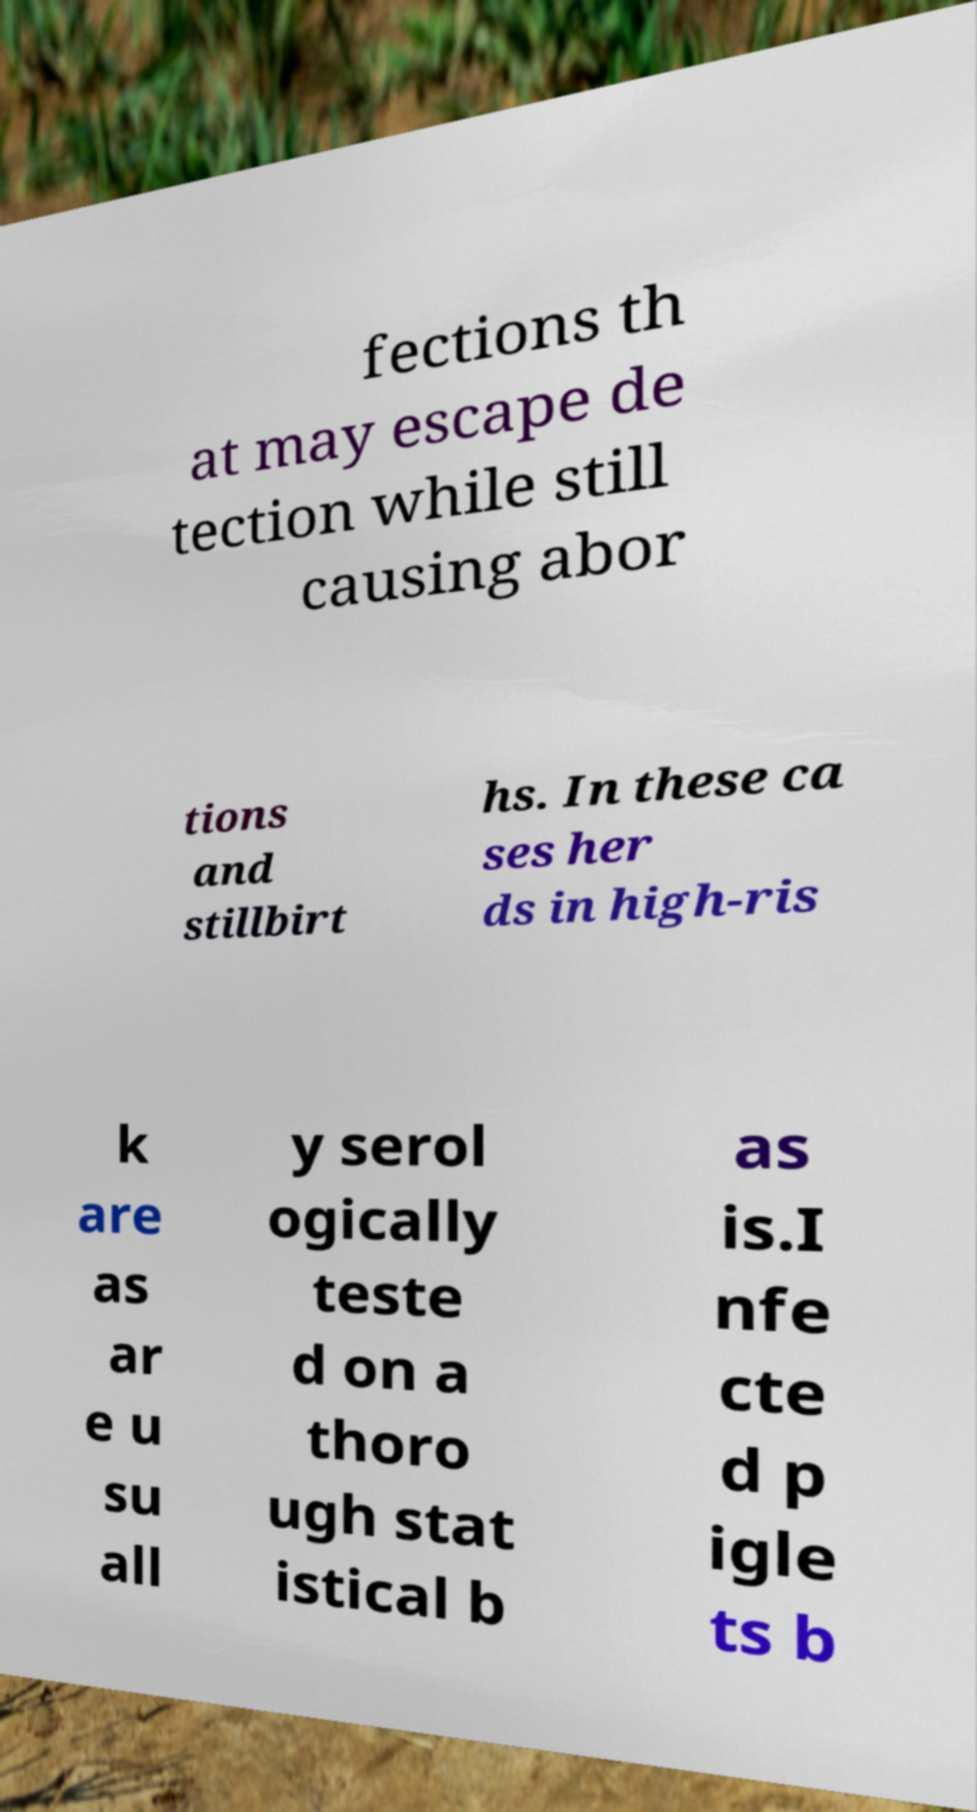I need the written content from this picture converted into text. Can you do that? fections th at may escape de tection while still causing abor tions and stillbirt hs. In these ca ses her ds in high-ris k are as ar e u su all y serol ogically teste d on a thoro ugh stat istical b as is.I nfe cte d p igle ts b 